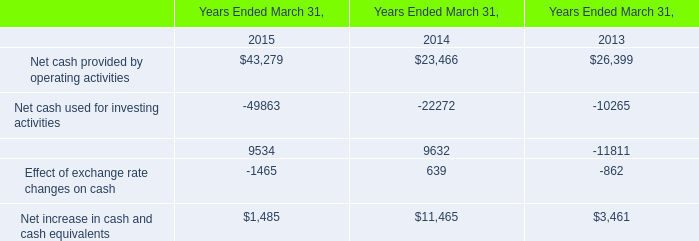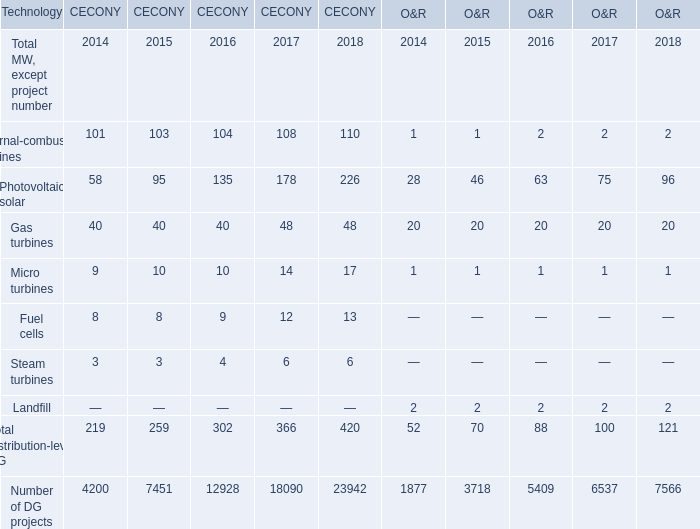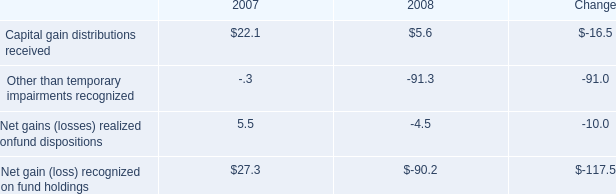Which year is Photovoltaic solar for CECONY the highest? 
Answer: 2018. 